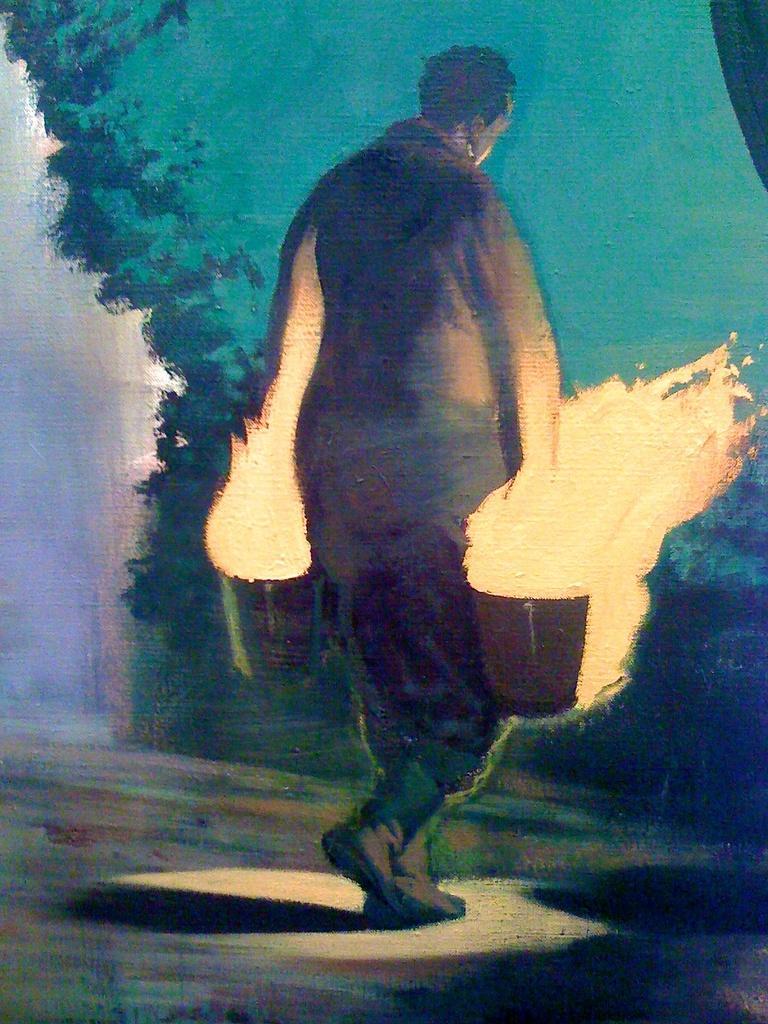Please provide a concise description of this image. In this image there is a painting of a person walking. 